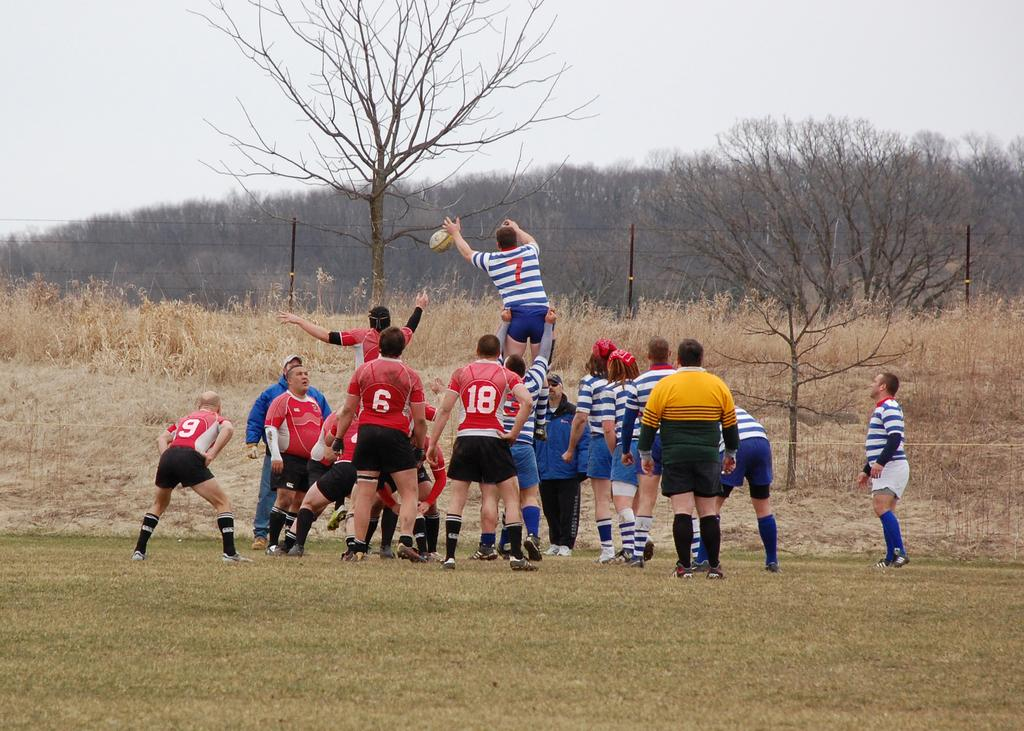What is the main subject of the image? There is a group of people on the ground in the image. What object is visible with the group of people? There is a ball in the image. What can be seen in the background of the image? There are trees, poles, and the sky visible in the background of the image. What type of underwear is the group of people wearing in the image? There is no information about the underwear of the people in the image, and therefore it cannot be determined. 